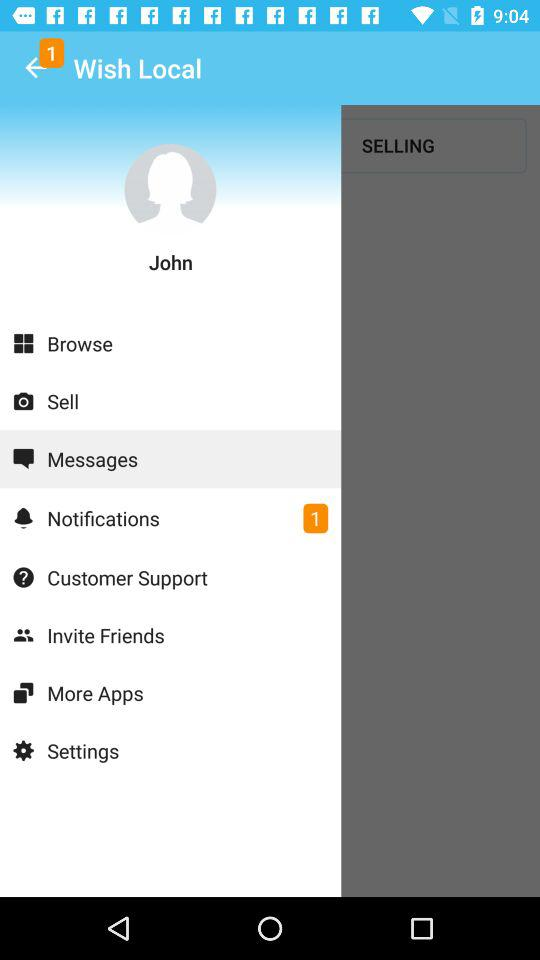How many unread notifications are there? There is 1 unread notification. 